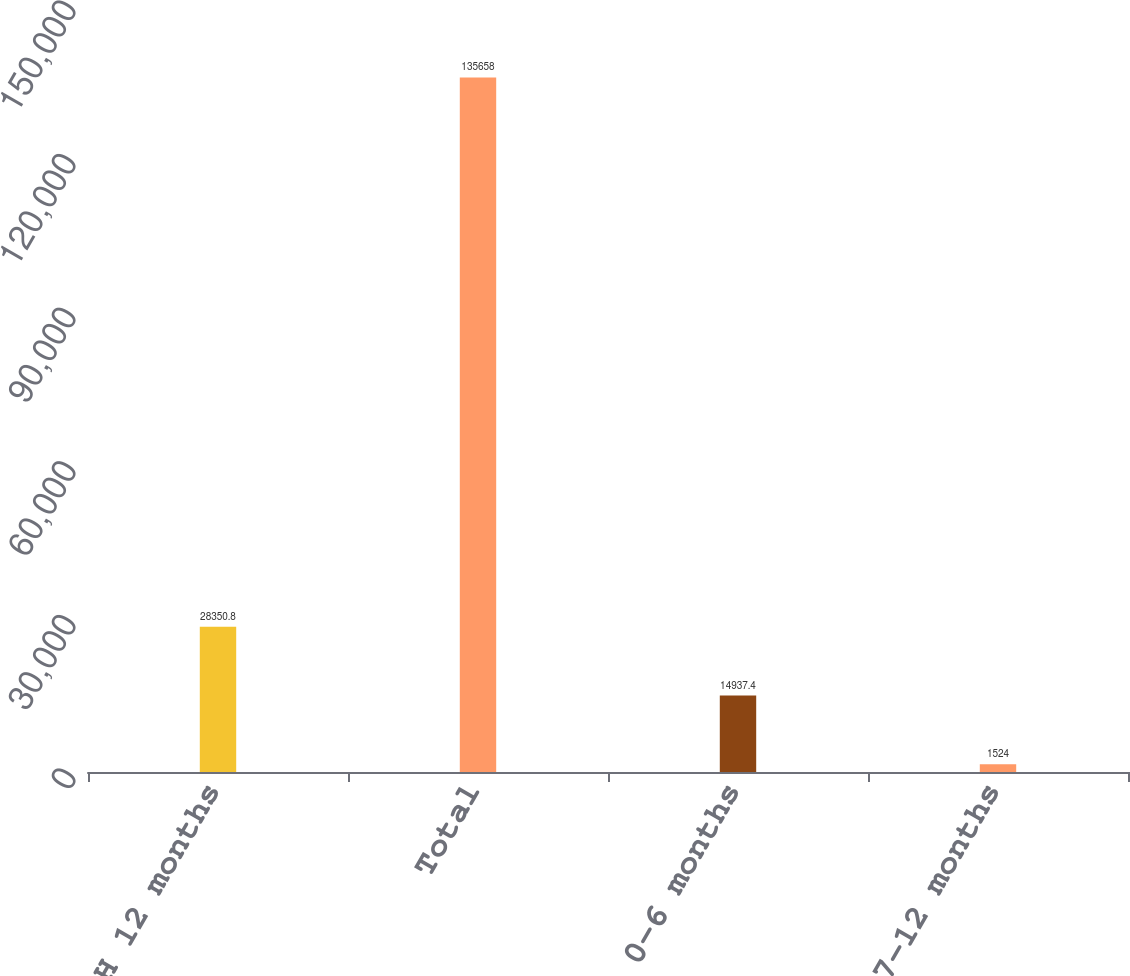Convert chart to OTSL. <chart><loc_0><loc_0><loc_500><loc_500><bar_chart><fcel>H 12 months<fcel>Total<fcel>0-6 months<fcel>7-12 months<nl><fcel>28350.8<fcel>135658<fcel>14937.4<fcel>1524<nl></chart> 